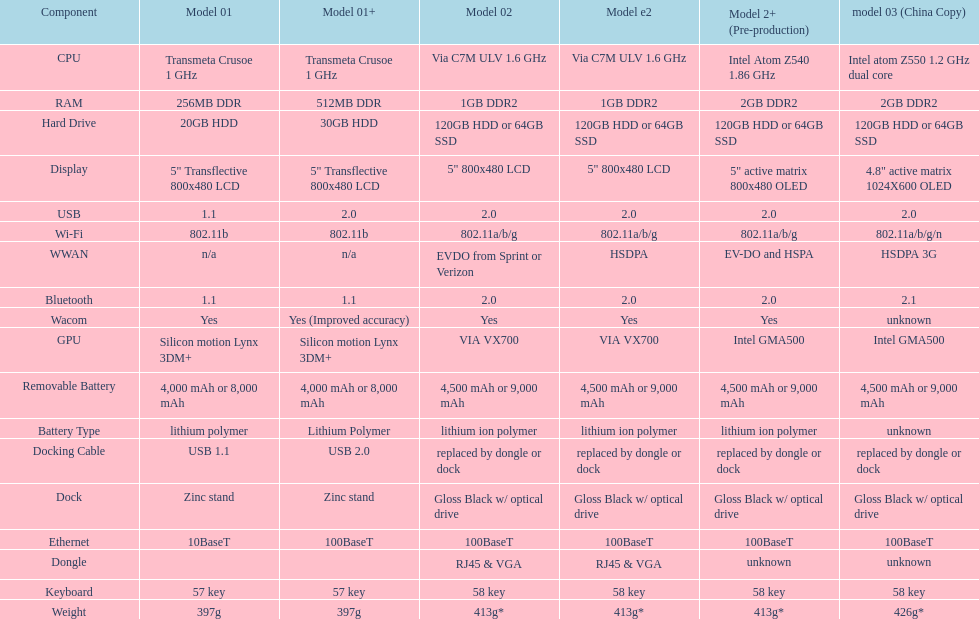How many models possess 2. 